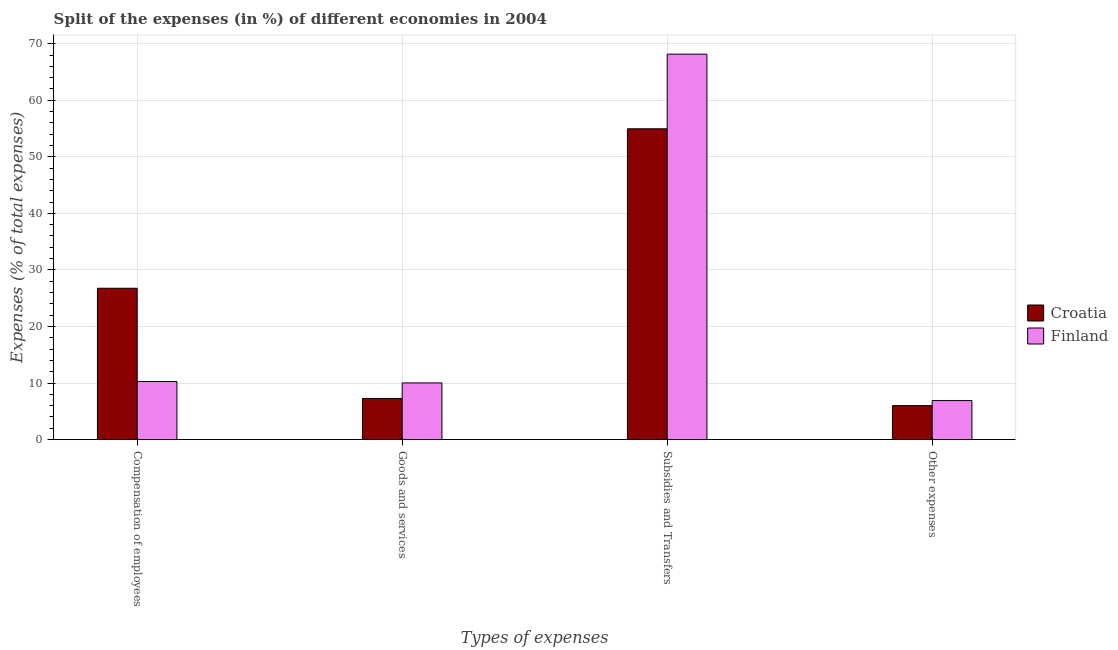How many different coloured bars are there?
Your answer should be compact. 2. How many groups of bars are there?
Your response must be concise. 4. How many bars are there on the 2nd tick from the left?
Offer a terse response. 2. How many bars are there on the 3rd tick from the right?
Your response must be concise. 2. What is the label of the 1st group of bars from the left?
Give a very brief answer. Compensation of employees. What is the percentage of amount spent on subsidies in Croatia?
Your response must be concise. 54.95. Across all countries, what is the maximum percentage of amount spent on other expenses?
Keep it short and to the point. 6.9. Across all countries, what is the minimum percentage of amount spent on other expenses?
Offer a terse response. 6.01. In which country was the percentage of amount spent on other expenses minimum?
Give a very brief answer. Croatia. What is the total percentage of amount spent on subsidies in the graph?
Ensure brevity in your answer.  123.1. What is the difference between the percentage of amount spent on subsidies in Finland and that in Croatia?
Keep it short and to the point. 13.2. What is the difference between the percentage of amount spent on subsidies in Finland and the percentage of amount spent on goods and services in Croatia?
Provide a short and direct response. 60.87. What is the average percentage of amount spent on other expenses per country?
Give a very brief answer. 6.46. What is the difference between the percentage of amount spent on other expenses and percentage of amount spent on subsidies in Finland?
Provide a succinct answer. -61.25. In how many countries, is the percentage of amount spent on goods and services greater than 26 %?
Provide a succinct answer. 0. What is the ratio of the percentage of amount spent on compensation of employees in Croatia to that in Finland?
Ensure brevity in your answer.  2.61. What is the difference between the highest and the second highest percentage of amount spent on compensation of employees?
Provide a succinct answer. 16.49. What is the difference between the highest and the lowest percentage of amount spent on other expenses?
Provide a short and direct response. 0.89. In how many countries, is the percentage of amount spent on goods and services greater than the average percentage of amount spent on goods and services taken over all countries?
Provide a short and direct response. 1. Is the sum of the percentage of amount spent on goods and services in Croatia and Finland greater than the maximum percentage of amount spent on subsidies across all countries?
Ensure brevity in your answer.  No. Is it the case that in every country, the sum of the percentage of amount spent on goods and services and percentage of amount spent on compensation of employees is greater than the sum of percentage of amount spent on subsidies and percentage of amount spent on other expenses?
Offer a very short reply. No. What does the 2nd bar from the right in Compensation of employees represents?
Keep it short and to the point. Croatia. Are all the bars in the graph horizontal?
Make the answer very short. No. What is the difference between two consecutive major ticks on the Y-axis?
Keep it short and to the point. 10. Does the graph contain any zero values?
Keep it short and to the point. No. How are the legend labels stacked?
Your response must be concise. Vertical. What is the title of the graph?
Give a very brief answer. Split of the expenses (in %) of different economies in 2004. Does "Tonga" appear as one of the legend labels in the graph?
Offer a terse response. No. What is the label or title of the X-axis?
Ensure brevity in your answer.  Types of expenses. What is the label or title of the Y-axis?
Your response must be concise. Expenses (% of total expenses). What is the Expenses (% of total expenses) in Croatia in Compensation of employees?
Give a very brief answer. 26.76. What is the Expenses (% of total expenses) in Finland in Compensation of employees?
Make the answer very short. 10.27. What is the Expenses (% of total expenses) in Croatia in Goods and services?
Your answer should be very brief. 7.28. What is the Expenses (% of total expenses) in Finland in Goods and services?
Offer a very short reply. 10.02. What is the Expenses (% of total expenses) in Croatia in Subsidies and Transfers?
Your response must be concise. 54.95. What is the Expenses (% of total expenses) in Finland in Subsidies and Transfers?
Offer a very short reply. 68.15. What is the Expenses (% of total expenses) in Croatia in Other expenses?
Your answer should be very brief. 6.01. What is the Expenses (% of total expenses) in Finland in Other expenses?
Your answer should be compact. 6.9. Across all Types of expenses, what is the maximum Expenses (% of total expenses) of Croatia?
Your answer should be compact. 54.95. Across all Types of expenses, what is the maximum Expenses (% of total expenses) of Finland?
Make the answer very short. 68.15. Across all Types of expenses, what is the minimum Expenses (% of total expenses) in Croatia?
Offer a terse response. 6.01. Across all Types of expenses, what is the minimum Expenses (% of total expenses) in Finland?
Provide a succinct answer. 6.9. What is the total Expenses (% of total expenses) in Croatia in the graph?
Offer a very short reply. 95. What is the total Expenses (% of total expenses) of Finland in the graph?
Offer a very short reply. 95.34. What is the difference between the Expenses (% of total expenses) in Croatia in Compensation of employees and that in Goods and services?
Keep it short and to the point. 19.48. What is the difference between the Expenses (% of total expenses) in Finland in Compensation of employees and that in Goods and services?
Keep it short and to the point. 0.25. What is the difference between the Expenses (% of total expenses) in Croatia in Compensation of employees and that in Subsidies and Transfers?
Give a very brief answer. -28.19. What is the difference between the Expenses (% of total expenses) of Finland in Compensation of employees and that in Subsidies and Transfers?
Offer a terse response. -57.88. What is the difference between the Expenses (% of total expenses) of Croatia in Compensation of employees and that in Other expenses?
Keep it short and to the point. 20.75. What is the difference between the Expenses (% of total expenses) of Finland in Compensation of employees and that in Other expenses?
Ensure brevity in your answer.  3.37. What is the difference between the Expenses (% of total expenses) in Croatia in Goods and services and that in Subsidies and Transfers?
Your answer should be very brief. -47.67. What is the difference between the Expenses (% of total expenses) of Finland in Goods and services and that in Subsidies and Transfers?
Your answer should be compact. -58.13. What is the difference between the Expenses (% of total expenses) in Croatia in Goods and services and that in Other expenses?
Your answer should be very brief. 1.27. What is the difference between the Expenses (% of total expenses) of Finland in Goods and services and that in Other expenses?
Your answer should be compact. 3.12. What is the difference between the Expenses (% of total expenses) of Croatia in Subsidies and Transfers and that in Other expenses?
Make the answer very short. 48.94. What is the difference between the Expenses (% of total expenses) in Finland in Subsidies and Transfers and that in Other expenses?
Keep it short and to the point. 61.25. What is the difference between the Expenses (% of total expenses) in Croatia in Compensation of employees and the Expenses (% of total expenses) in Finland in Goods and services?
Make the answer very short. 16.74. What is the difference between the Expenses (% of total expenses) of Croatia in Compensation of employees and the Expenses (% of total expenses) of Finland in Subsidies and Transfers?
Your answer should be compact. -41.39. What is the difference between the Expenses (% of total expenses) in Croatia in Compensation of employees and the Expenses (% of total expenses) in Finland in Other expenses?
Keep it short and to the point. 19.86. What is the difference between the Expenses (% of total expenses) of Croatia in Goods and services and the Expenses (% of total expenses) of Finland in Subsidies and Transfers?
Provide a succinct answer. -60.87. What is the difference between the Expenses (% of total expenses) of Croatia in Goods and services and the Expenses (% of total expenses) of Finland in Other expenses?
Ensure brevity in your answer.  0.38. What is the difference between the Expenses (% of total expenses) of Croatia in Subsidies and Transfers and the Expenses (% of total expenses) of Finland in Other expenses?
Make the answer very short. 48.05. What is the average Expenses (% of total expenses) in Croatia per Types of expenses?
Provide a succinct answer. 23.75. What is the average Expenses (% of total expenses) of Finland per Types of expenses?
Your answer should be compact. 23.84. What is the difference between the Expenses (% of total expenses) in Croatia and Expenses (% of total expenses) in Finland in Compensation of employees?
Ensure brevity in your answer.  16.49. What is the difference between the Expenses (% of total expenses) of Croatia and Expenses (% of total expenses) of Finland in Goods and services?
Provide a succinct answer. -2.74. What is the difference between the Expenses (% of total expenses) of Croatia and Expenses (% of total expenses) of Finland in Subsidies and Transfers?
Your answer should be very brief. -13.2. What is the difference between the Expenses (% of total expenses) of Croatia and Expenses (% of total expenses) of Finland in Other expenses?
Make the answer very short. -0.89. What is the ratio of the Expenses (% of total expenses) of Croatia in Compensation of employees to that in Goods and services?
Offer a very short reply. 3.68. What is the ratio of the Expenses (% of total expenses) of Finland in Compensation of employees to that in Goods and services?
Keep it short and to the point. 1.02. What is the ratio of the Expenses (% of total expenses) of Croatia in Compensation of employees to that in Subsidies and Transfers?
Offer a terse response. 0.49. What is the ratio of the Expenses (% of total expenses) of Finland in Compensation of employees to that in Subsidies and Transfers?
Provide a succinct answer. 0.15. What is the ratio of the Expenses (% of total expenses) of Croatia in Compensation of employees to that in Other expenses?
Ensure brevity in your answer.  4.45. What is the ratio of the Expenses (% of total expenses) of Finland in Compensation of employees to that in Other expenses?
Provide a succinct answer. 1.49. What is the ratio of the Expenses (% of total expenses) in Croatia in Goods and services to that in Subsidies and Transfers?
Make the answer very short. 0.13. What is the ratio of the Expenses (% of total expenses) in Finland in Goods and services to that in Subsidies and Transfers?
Provide a succinct answer. 0.15. What is the ratio of the Expenses (% of total expenses) of Croatia in Goods and services to that in Other expenses?
Your answer should be compact. 1.21. What is the ratio of the Expenses (% of total expenses) in Finland in Goods and services to that in Other expenses?
Offer a terse response. 1.45. What is the ratio of the Expenses (% of total expenses) in Croatia in Subsidies and Transfers to that in Other expenses?
Provide a succinct answer. 9.14. What is the ratio of the Expenses (% of total expenses) of Finland in Subsidies and Transfers to that in Other expenses?
Your response must be concise. 9.87. What is the difference between the highest and the second highest Expenses (% of total expenses) of Croatia?
Your answer should be very brief. 28.19. What is the difference between the highest and the second highest Expenses (% of total expenses) in Finland?
Provide a short and direct response. 57.88. What is the difference between the highest and the lowest Expenses (% of total expenses) in Croatia?
Provide a succinct answer. 48.94. What is the difference between the highest and the lowest Expenses (% of total expenses) of Finland?
Your answer should be compact. 61.25. 